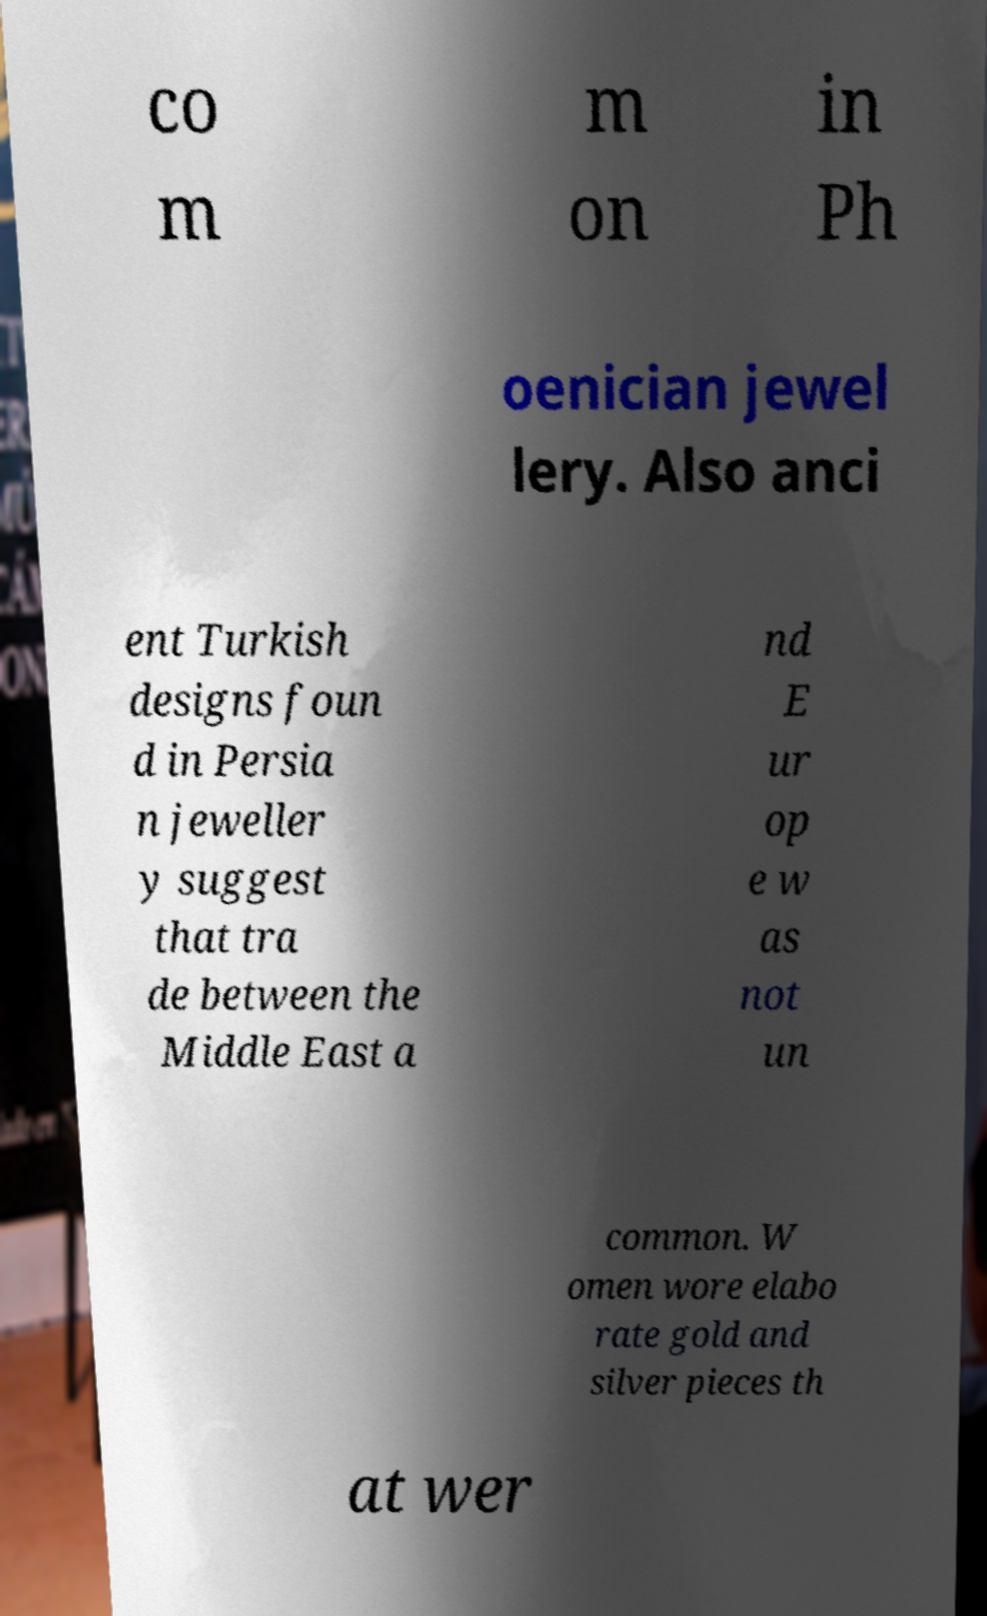Can you read and provide the text displayed in the image?This photo seems to have some interesting text. Can you extract and type it out for me? co m m on in Ph oenician jewel lery. Also anci ent Turkish designs foun d in Persia n jeweller y suggest that tra de between the Middle East a nd E ur op e w as not un common. W omen wore elabo rate gold and silver pieces th at wer 